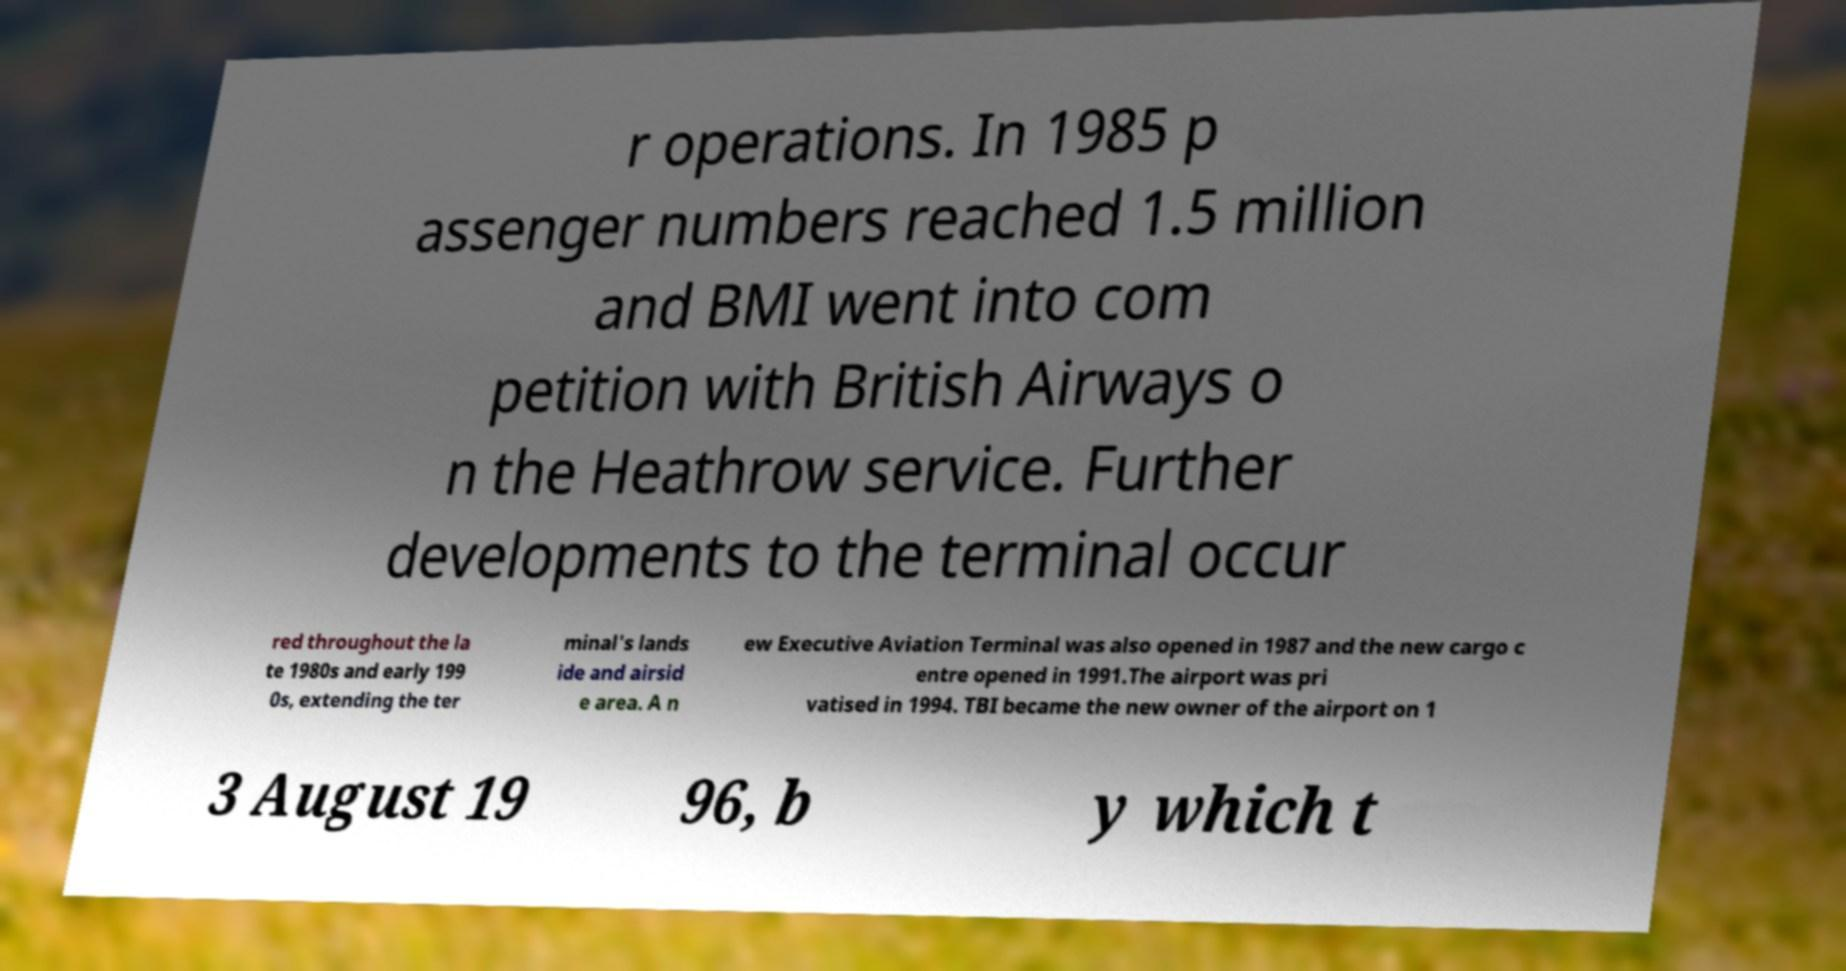Can you accurately transcribe the text from the provided image for me? r operations. In 1985 p assenger numbers reached 1.5 million and BMI went into com petition with British Airways o n the Heathrow service. Further developments to the terminal occur red throughout the la te 1980s and early 199 0s, extending the ter minal's lands ide and airsid e area. A n ew Executive Aviation Terminal was also opened in 1987 and the new cargo c entre opened in 1991.The airport was pri vatised in 1994. TBI became the new owner of the airport on 1 3 August 19 96, b y which t 